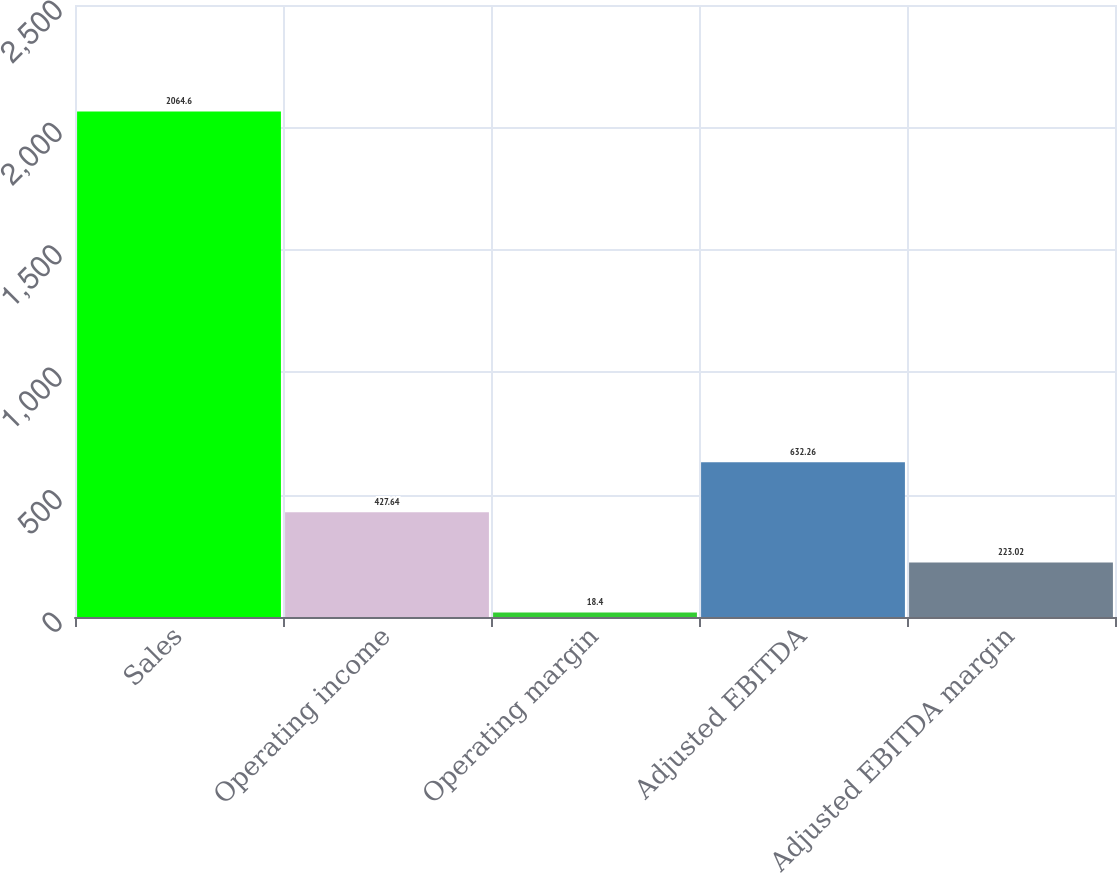<chart> <loc_0><loc_0><loc_500><loc_500><bar_chart><fcel>Sales<fcel>Operating income<fcel>Operating margin<fcel>Adjusted EBITDA<fcel>Adjusted EBITDA margin<nl><fcel>2064.6<fcel>427.64<fcel>18.4<fcel>632.26<fcel>223.02<nl></chart> 